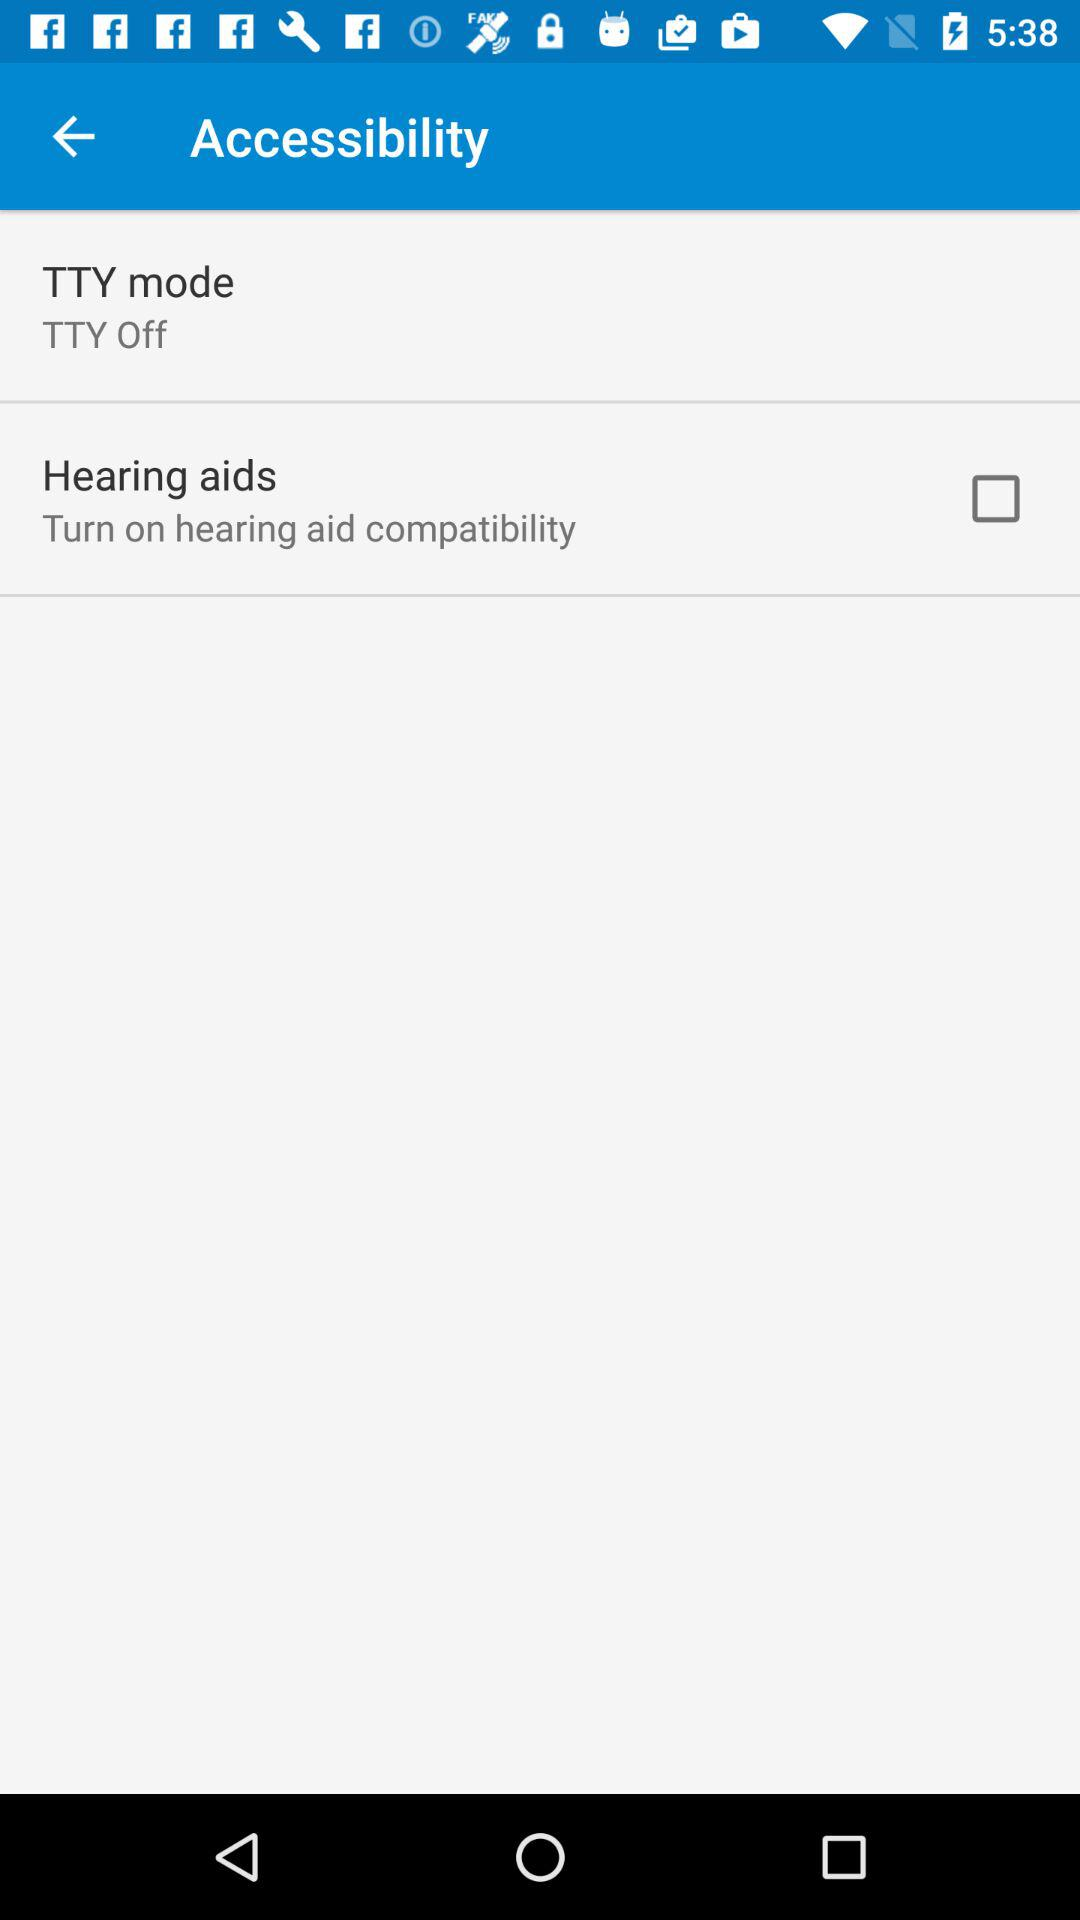What is the current status of "TTY mode"? The current status is "off". 